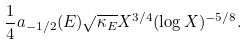<formula> <loc_0><loc_0><loc_500><loc_500>\frac { 1 } { 4 } a _ { - 1 / 2 } ( E ) \sqrt { \kappa _ { E } } X ^ { 3 / 4 } ( \log X ) ^ { - 5 / 8 } .</formula> 